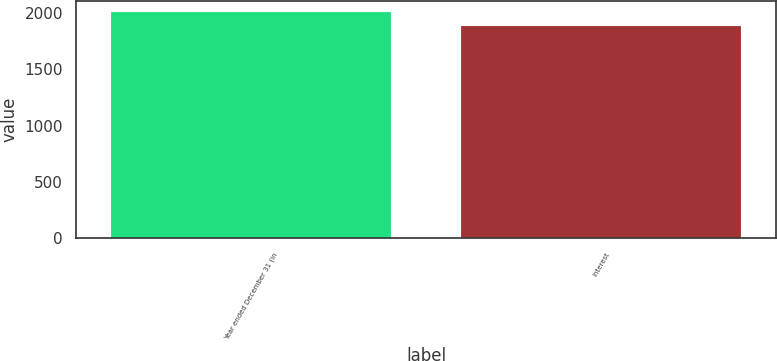Convert chart. <chart><loc_0><loc_0><loc_500><loc_500><bar_chart><fcel>Year ended December 31 (in<fcel>Interest<nl><fcel>2006<fcel>1880<nl></chart> 